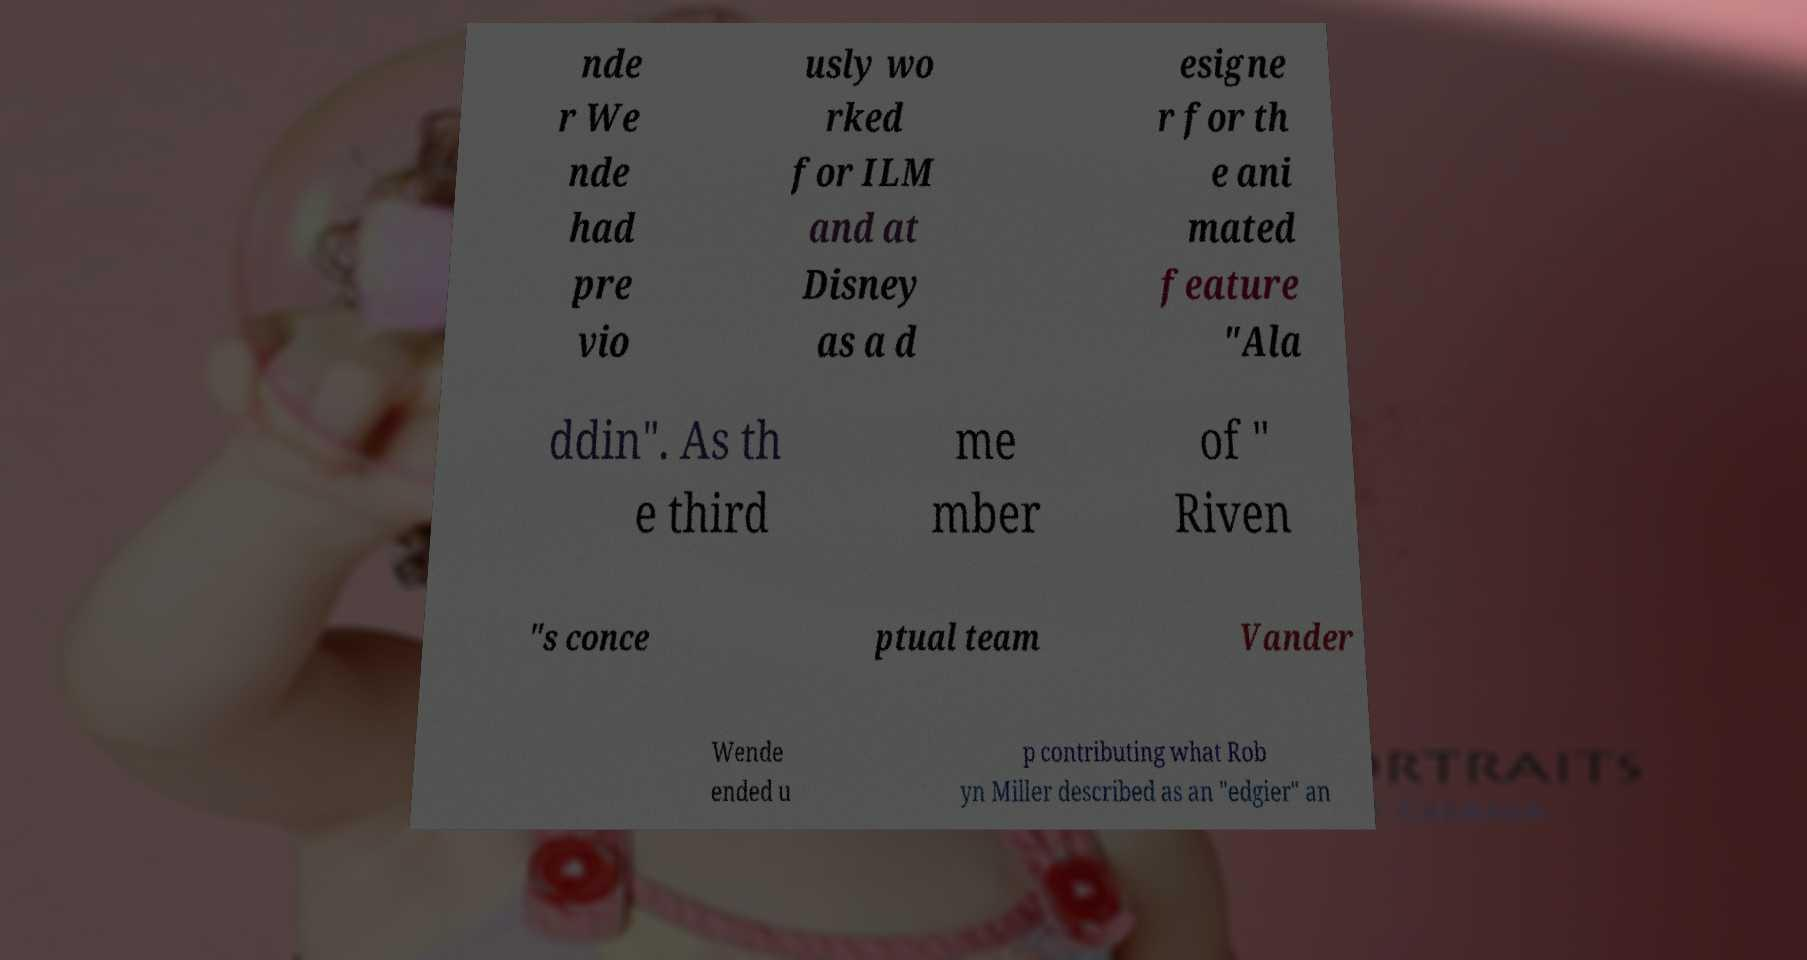There's text embedded in this image that I need extracted. Can you transcribe it verbatim? nde r We nde had pre vio usly wo rked for ILM and at Disney as a d esigne r for th e ani mated feature "Ala ddin". As th e third me mber of " Riven "s conce ptual team Vander Wende ended u p contributing what Rob yn Miller described as an "edgier" an 